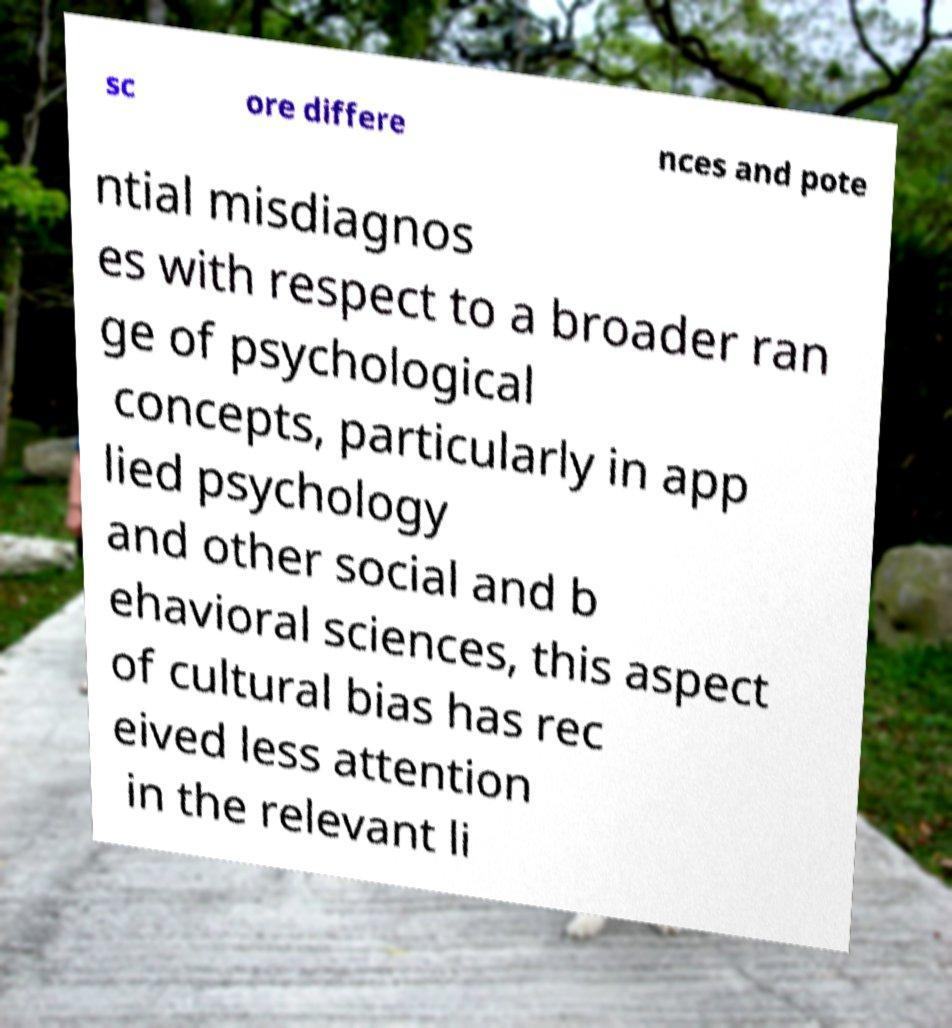Can you read and provide the text displayed in the image?This photo seems to have some interesting text. Can you extract and type it out for me? sc ore differe nces and pote ntial misdiagnos es with respect to a broader ran ge of psychological concepts, particularly in app lied psychology and other social and b ehavioral sciences, this aspect of cultural bias has rec eived less attention in the relevant li 